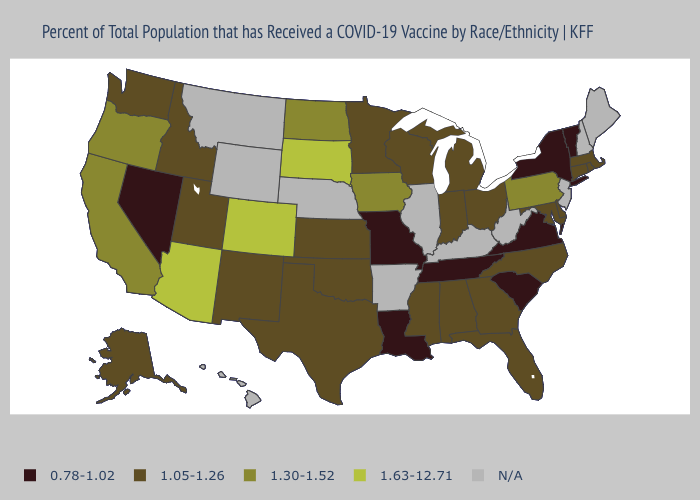What is the value of Alaska?
Quick response, please. 1.05-1.26. Which states have the highest value in the USA?
Concise answer only. Arizona, Colorado, South Dakota. Name the states that have a value in the range 0.78-1.02?
Concise answer only. Louisiana, Missouri, Nevada, New York, South Carolina, Tennessee, Vermont, Virginia. What is the value of Alaska?
Short answer required. 1.05-1.26. What is the value of Wyoming?
Give a very brief answer. N/A. Name the states that have a value in the range 0.78-1.02?
Be succinct. Louisiana, Missouri, Nevada, New York, South Carolina, Tennessee, Vermont, Virginia. What is the value of Illinois?
Answer briefly. N/A. Name the states that have a value in the range N/A?
Write a very short answer. Arkansas, Hawaii, Illinois, Kentucky, Maine, Montana, Nebraska, New Hampshire, New Jersey, West Virginia, Wyoming. Name the states that have a value in the range 1.30-1.52?
Answer briefly. California, Iowa, North Dakota, Oregon, Pennsylvania. Does Arizona have the highest value in the USA?
Concise answer only. Yes. What is the value of Maine?
Give a very brief answer. N/A. Which states have the lowest value in the MidWest?
Be succinct. Missouri. What is the lowest value in the USA?
Be succinct. 0.78-1.02. 